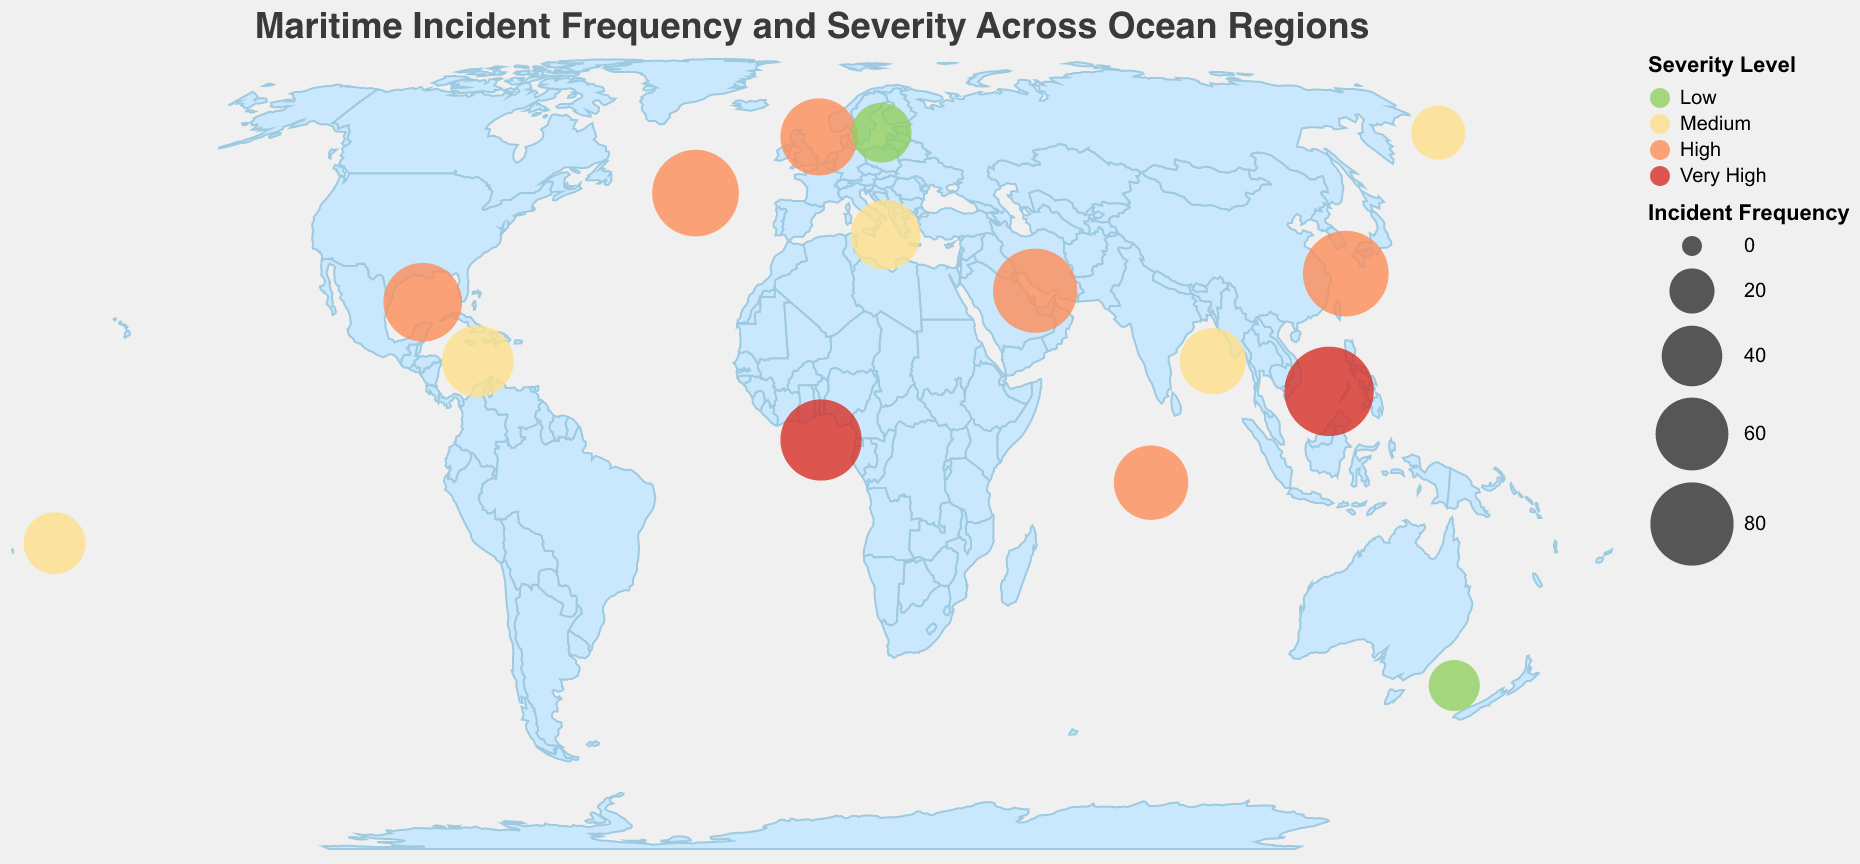Which ocean region has the highest frequency of maritime incidents? From the plot, identify the data point with the largest circle, indicating the highest incident frequency.
Answer: South China Sea What is the severity level of the maritime incidents in the Gulf of Guinea? Locate the Gulf of Guinea on the map and check the color representing the severity level.
Answer: Very High How does the incident frequency in the Mediterranean Sea compare to that in the Caribbean Sea? Compare the size of the circles representing the Mediterranean Sea and the Caribbean Sea.
Answer: The Mediterranean Sea has a lower frequency (55) compared to the Caribbean Sea (58) Which regions have a "High" severity level for maritime incidents? Identify the circles colored in the shade representing "High" severity on the map.
Answer: North Atlantic, Indian Ocean, Gulf of Mexico, North Sea, Persian Gulf, East China Sea What is the average incident frequency across regions with "Medium" severity? Sum the incident frequencies of regions with "Medium" severity and divide by the number of such regions {(42+55+58+31+49)/5}.
Answer: 47 Which ocean region, located at approximately 57° latitude, has an incident frequency of 68? Identify the region's position on the map and cross-check it with the incident frequency and latitude.
Answer: North Sea Are there more maritime incidents in the Gulf of Mexico or the Persian Gulf? Compare the circles representing the Gulf of Mexico and the Persian Gulf.
Answer: Gulf of Mexico What is the total incident frequency for regions with "Very High" severity? Add up the incident frequencies for regions marked with "Very High" severity (South China Sea, Gulf of Guinea).
Answer: 169 Which region with "Low" severity has an incident frequency closest to 30? Identify regions with "Low" severity and compare their incident frequencies.
Answer: Tasman Sea In which hemisphere are most high-severity maritime incidents located? Determine if more regions with "High" severity fall in the northern or southern hemisphere using latitude coordinates.
Answer: Northern Hemisphere 